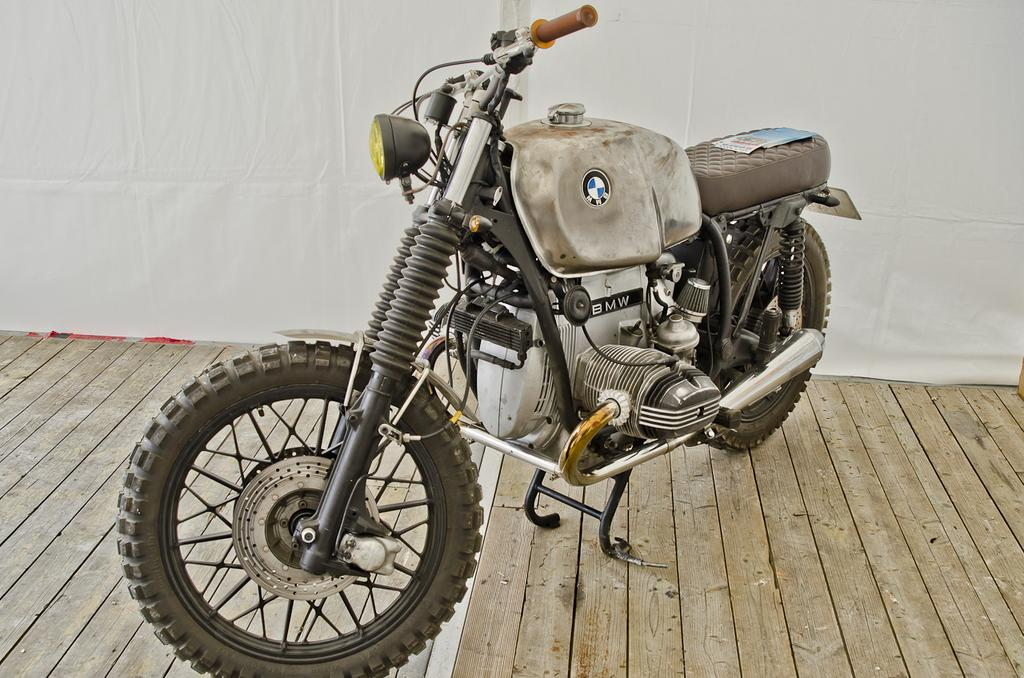What is the main object in the image? There is a bike in the image. What is the bike resting on? The bike is on a wooden surface. What can be seen in the background of the image? There is a white color cloth in the background of the image. What type of work is being performed on the bike in the image? There is no indication of any work being performed on the bike in the image. 